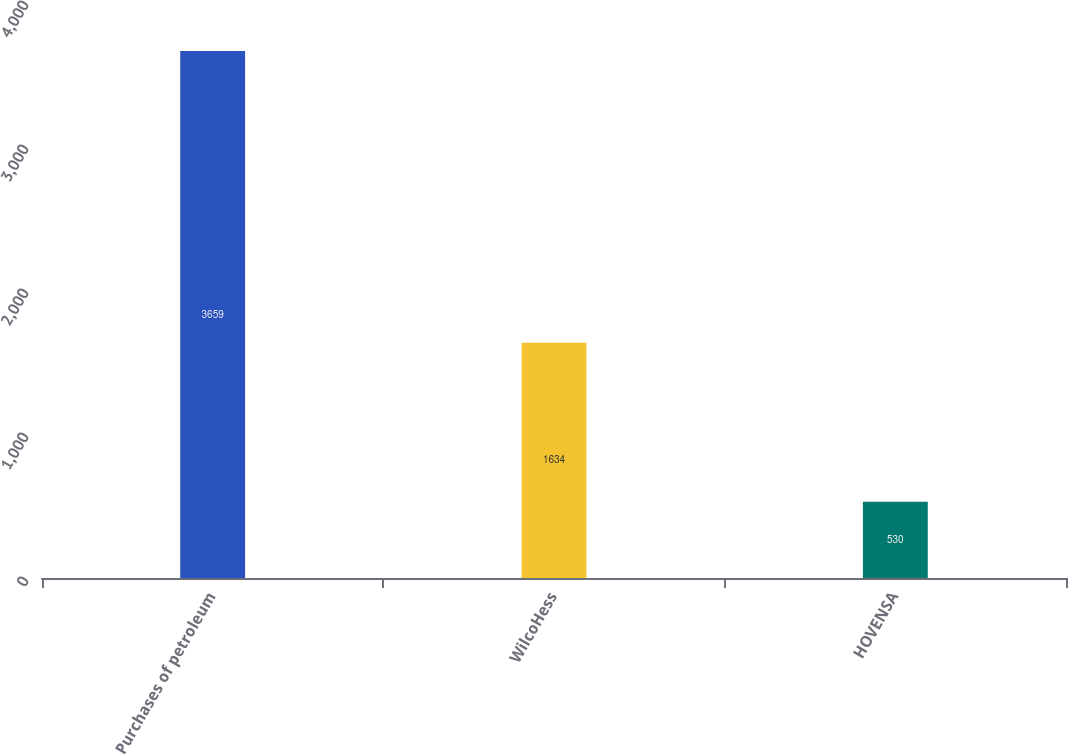Convert chart. <chart><loc_0><loc_0><loc_500><loc_500><bar_chart><fcel>Purchases of petroleum<fcel>WilcoHess<fcel>HOVENSA<nl><fcel>3659<fcel>1634<fcel>530<nl></chart> 